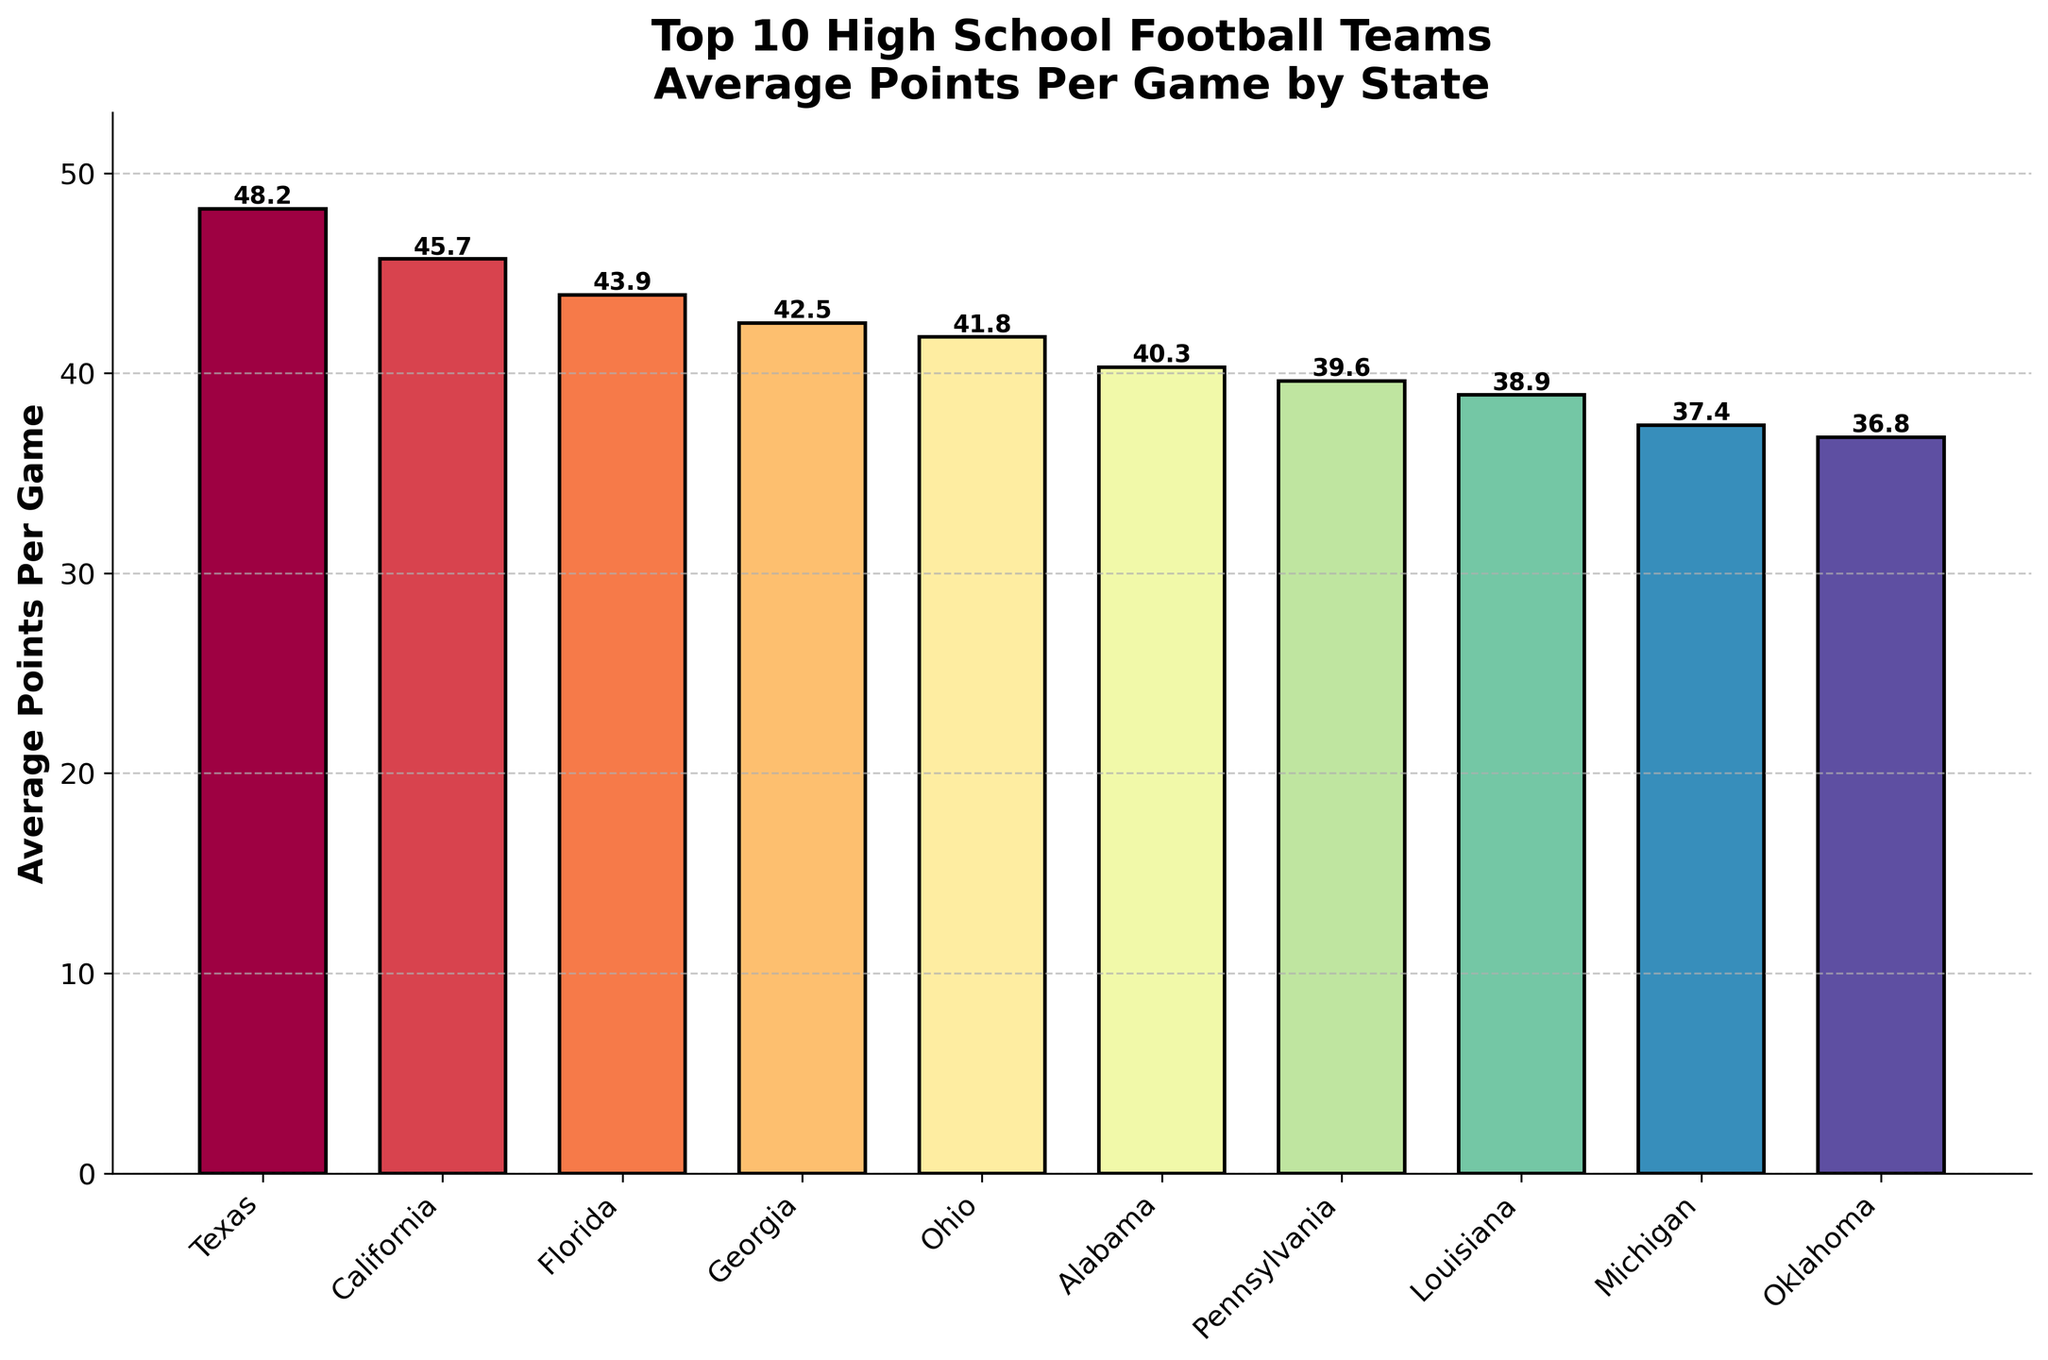What state has the highest average points per game? Texas has the highest average points per game with 48.2. Check the bar with the greatest height and the corresponding state label.
Answer: Texas Which state scores more on average, Georgia or California? California scores more on average, with 45.7 points per game compared to Georgia's 42.5. Compare the heights of the bars for Georgia and California.
Answer: California What is the difference in average points scored per game between Texas and Oklahoma? The difference is found by subtracting Oklahoma's average (36.8) from Texas's average (48.2): 48.2 - 36.8 = 11.4.
Answer: 11.4 Which state has the lowest average points per game? Oklahoma has the lowest average points per game at 36.8. Identify the bar with the shortest height and the corresponding state label.
Answer: Oklahoma How many states have an average points per game greater than 40? The states with average points per game greater than 40 are Texas, California, Florida, Georgia, and Ohio, making a total of 5 states. Count the number of bars with values greater than 40.
Answer: 5 Do Texas and California together average over 90 points per game? Texas scores 48.2 and California scores 45.7. Together, they average 48.2 + 45.7 = 93.9, which is over 90 points per game.
Answer: Yes Which states have an average points per game within a range of 38 to 40? The states Pennsylvania (39.6) and Louisiana (38.9) fall within the range of 38 to 40 points per game. Identify the bars whose heights represent values between 38 and 40.
Answer: Pennsylvania, Louisiana Is there a significant visual difference between the points per game of Texas and Pennsylvania? Yes, Texas's bar is much taller (48.2) compared to Pennsylvania's (39.6), indicating a significant difference visually.
Answer: Yes What is the total average points per game for all states combined? Sum the average points per game for all states: 48.2 + 45.7 + 43.9 + 42.5 + 41.8 + 40.3 + 39.6 + 38.9 + 37.4 + 36.8 = 415.1.
Answer: 415.1 What percentage more does Texas score on average compared to Alabama? Calculate the percentage increase from Alabama (40.3) to Texas (48.2): ((48.2 - 40.3) / 40.3) * 100 ≈ 19.6%.
Answer: 19.6% 